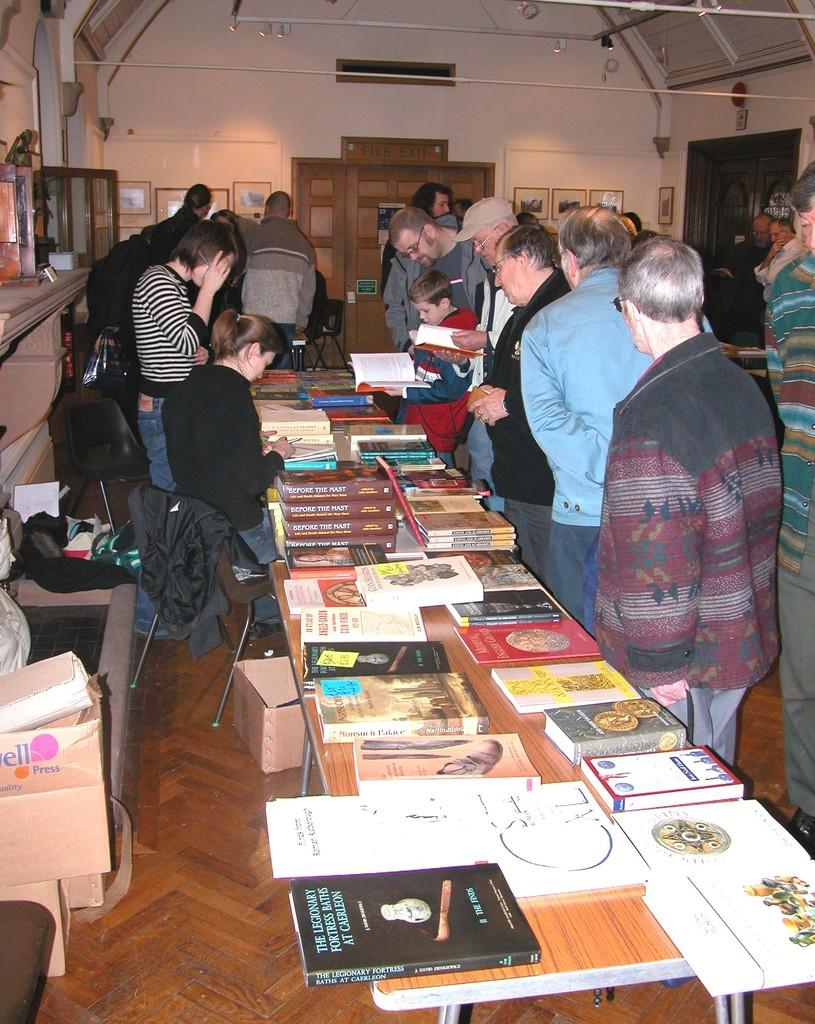What is happening in the image? There are people standing in the image. What is in front of the people? There is a table in front of the people. What can be seen on the table? The table has many books on it. What type of bread can be seen on the table in the image? There is no bread present on the table in the image; it has many books instead. 